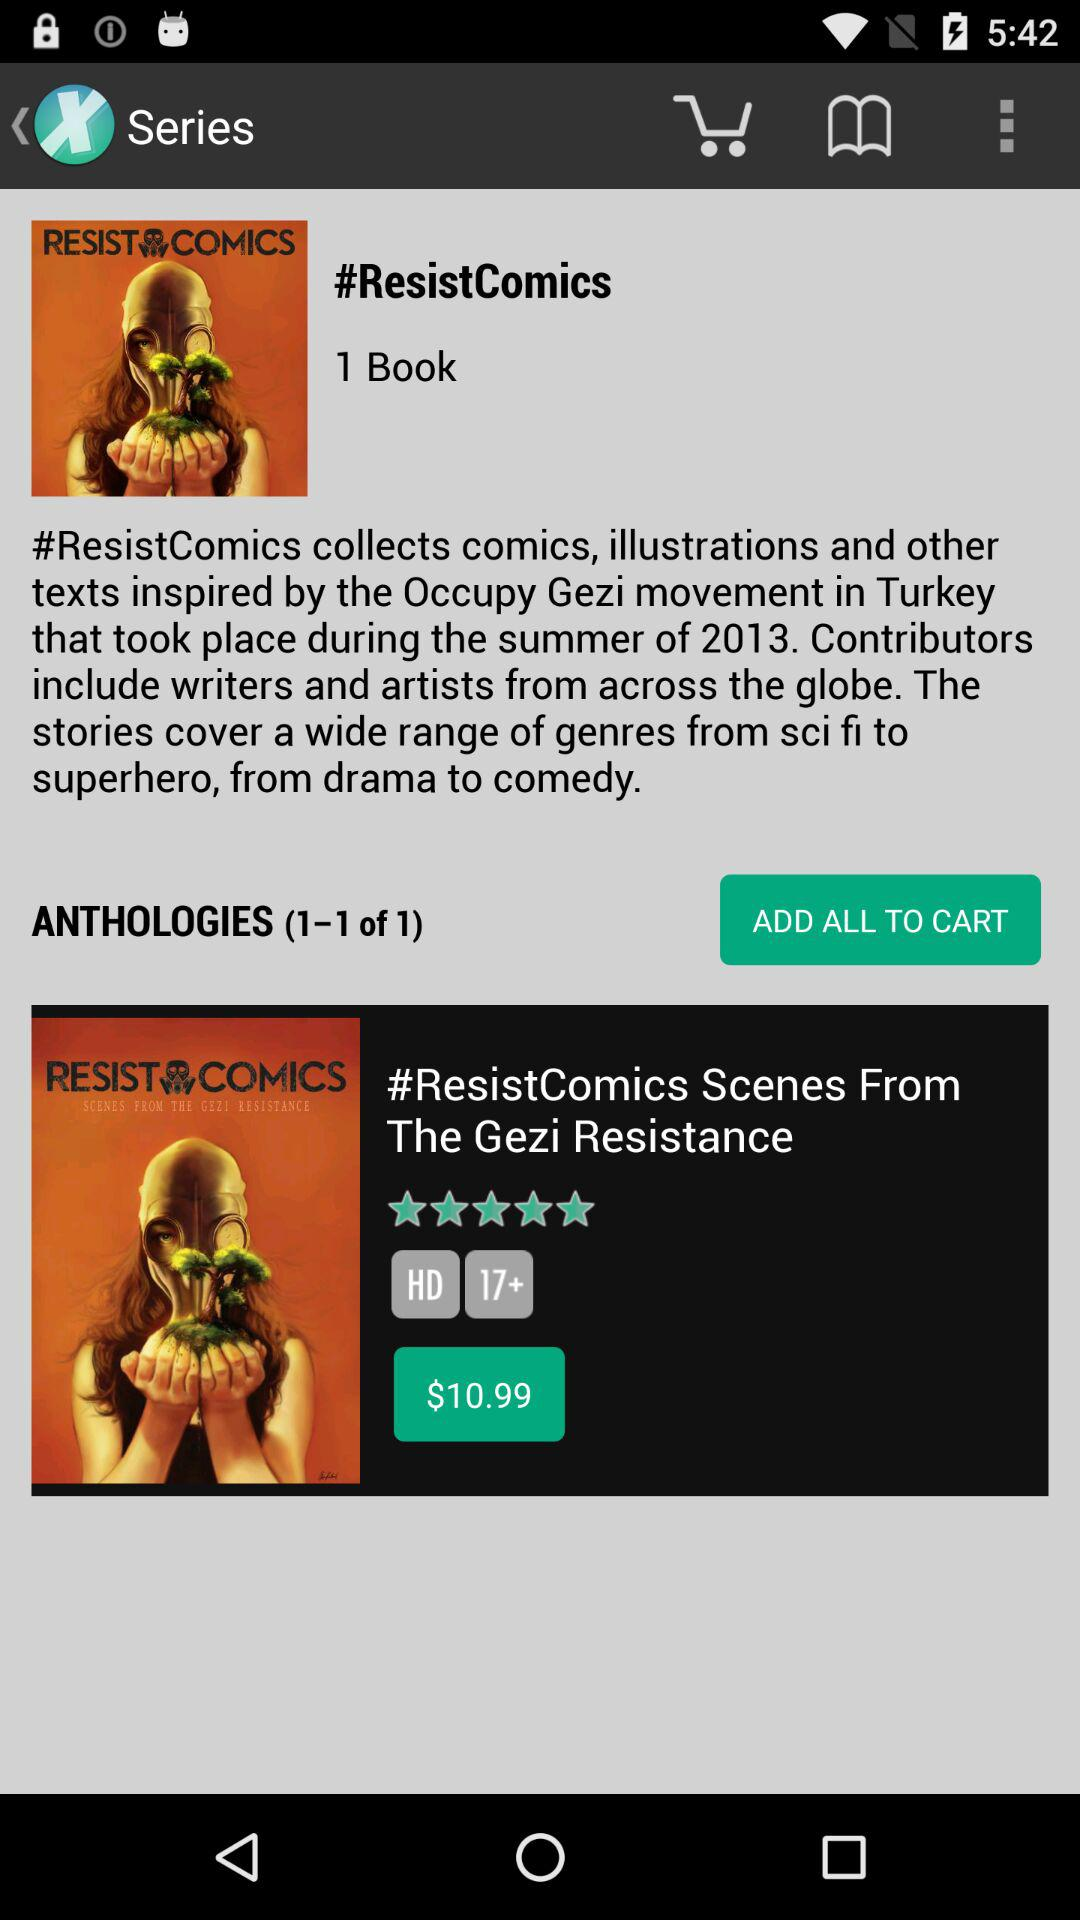How many books are there in the ResistComics series?
Answer the question using a single word or phrase. 1 